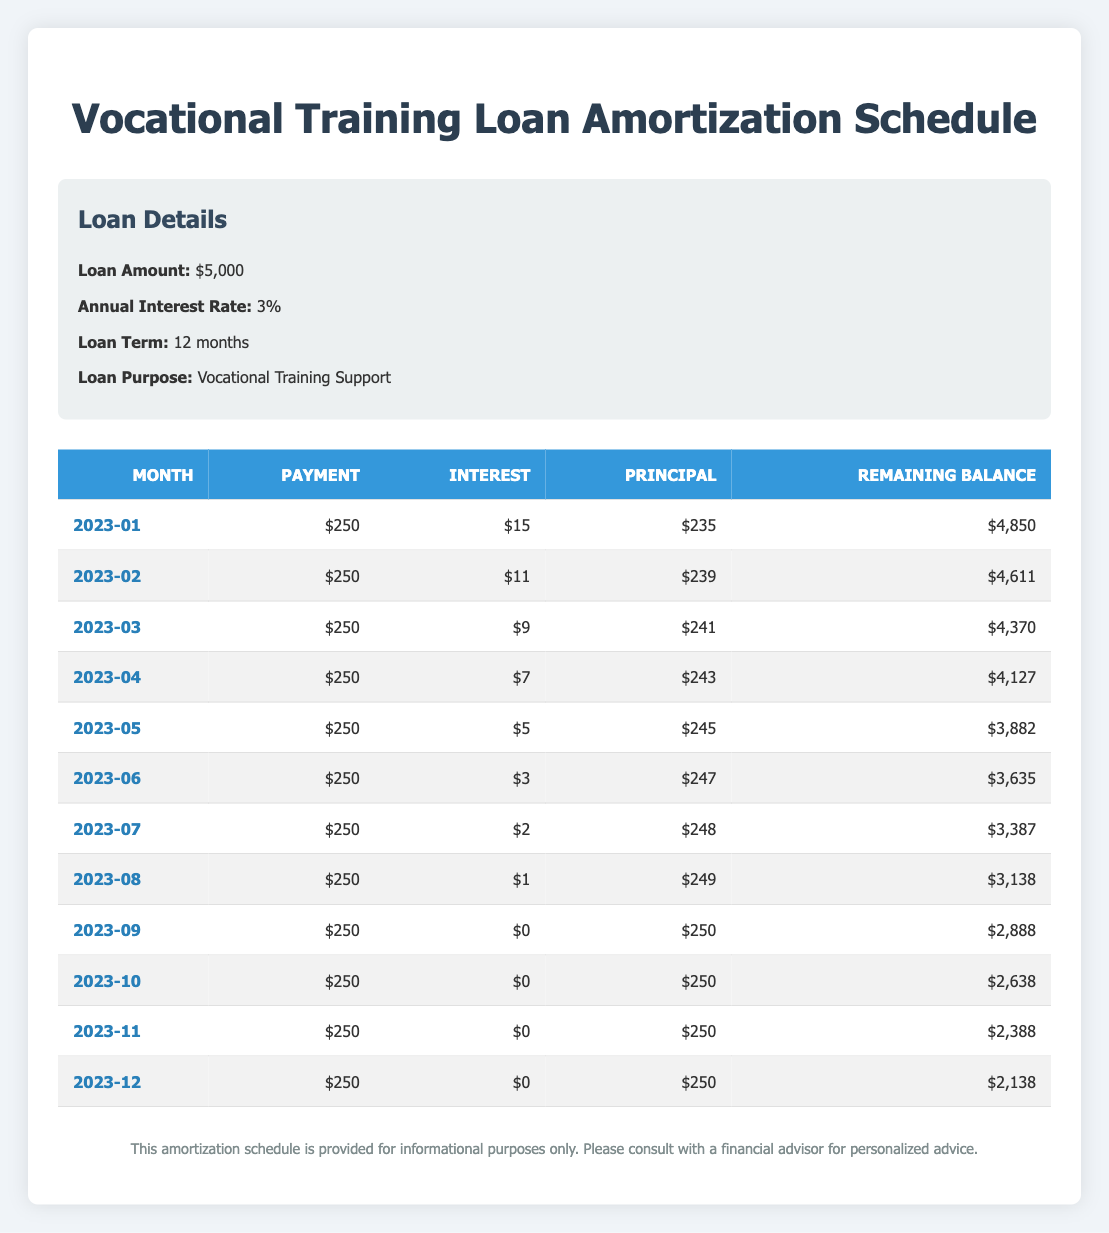What was the payment amount for each month? Each month shows a consistent payment of 250, as listed in the second column of the table for each month from January to December.
Answer: 250 What is the total interest paid over the loan term? The total interest paid is the sum of the interest amounts from each month: (15 + 11 + 9 + 7 + 5 + 3 + 2 + 1 + 0 + 0 + 0 + 0) = 53.
Answer: 53 What was the remaining balance after the payment in July? The remaining balance after the payment in July is listed in the last column for that month, which is 3,387.
Answer: 3,387 Did the principal amount paid ever exceed the interest amount paid during the loan term? In the month of January, the principal payment was 235 while the interest was 15. Every subsequent month continues this trend with principal consistently greater than interest.
Answer: Yes What is the average principal payment across all months? The principal payments for each month are: (235 + 239 + 241 + 243 + 245 + 247 + 248 + 249 + 250 + 250 + 250 + 250) = 2,988. To find the average, we divide this by 12 months: 2,988 / 12 = 249.
Answer: 249 How much did the remaining balance decrease from January to September? The remaining balance in January was 4,850 and in September was 2,888. The decrease is 4,850 - 2,888 = 1,962.
Answer: 1,962 Is it true that the interest amount paid was zero for the last four months? Looking at the table for the months of September, October, November, and December, the interest amounts are indeed all listed as zero.
Answer: Yes What is the total principal paid by the end of the loan term? The total principal paid is the sum of principal amounts from each month. Adding them up gives: (235 + 239 + 241 + 243 + 245 + 247 + 248 + 249 + 250 + 250 + 250 + 250) = 2,988.
Answer: 2,988 